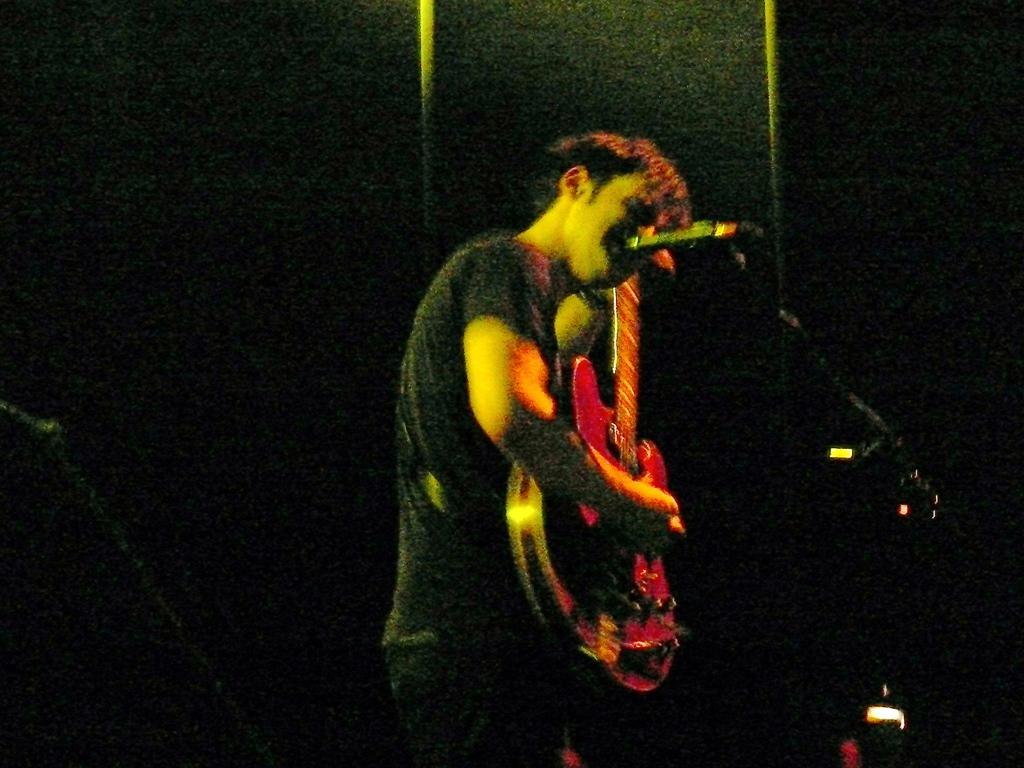What is the main subject of the image? The main subject of the image is a man. What is the man doing in the image? The man is standing and playing a guitar. What type of eggnog is the man drinking while playing the guitar in the image? There is no eggnog present in the image, and the man is not shown drinking anything. 